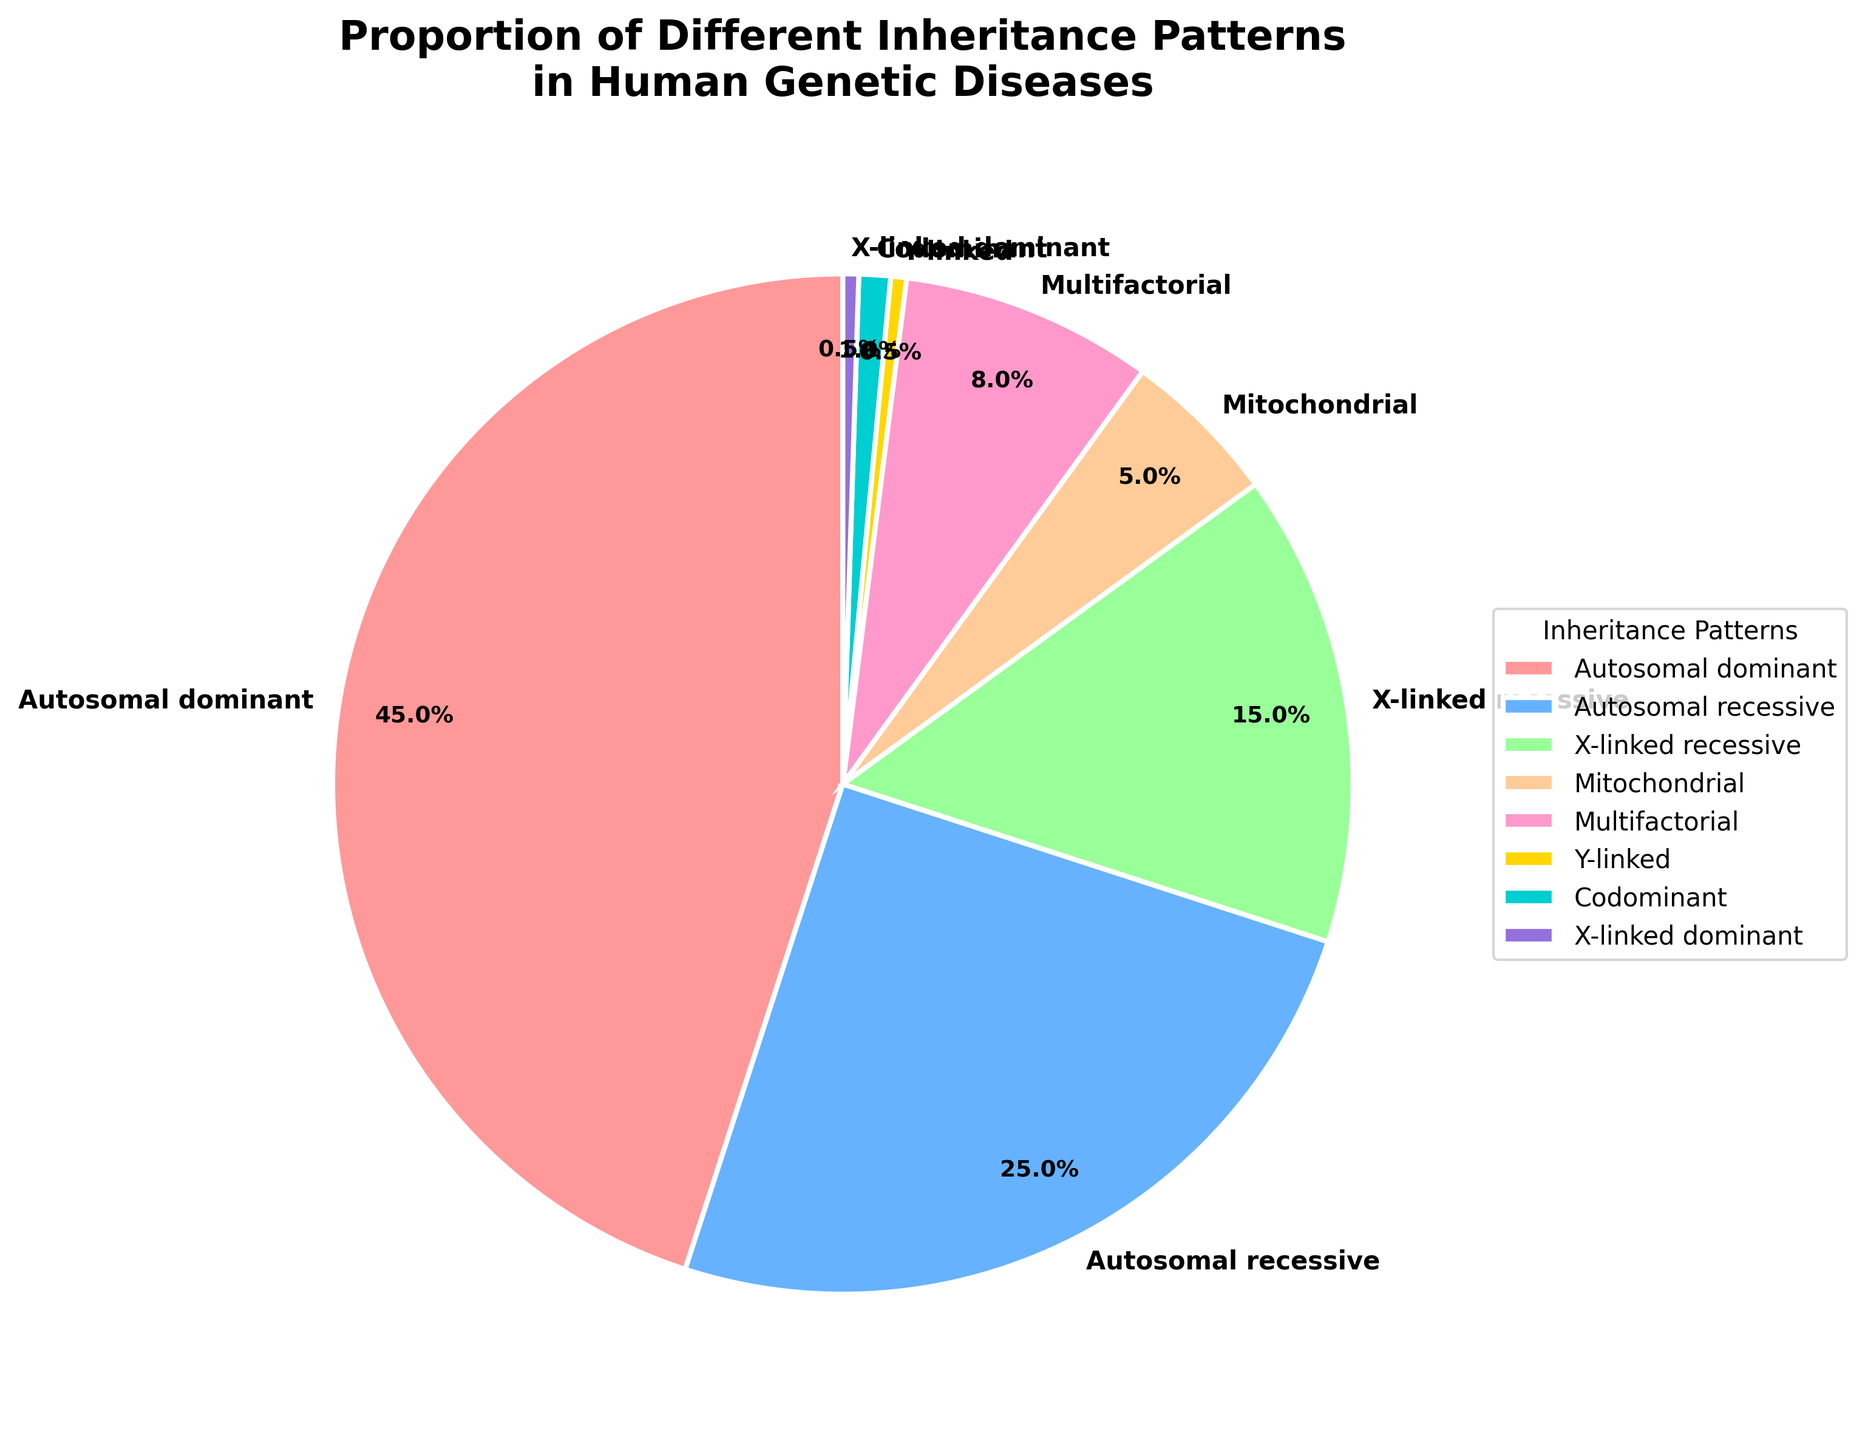What proportion of genetic diseases are inherited through Autosomal dominant patterns? From the pie chart, find the sector labeled "Autosomal dominant" and read the percentage value presented.
Answer: 45% Which inheritance pattern has the smallest representation in the pie chart? Look for the sector with the smallest percentage value. The smallest slice is labeled "Y-linked" and "X-linked dominant", both contributing 0.5%.
Answer: Y-linked and X-linked dominant How do the proportions of Autosomal recessive and Multifactorial diseases compare? Identify the percentages for both Autosomal recessive (25%) and Multifactorial (8%). Autosomal recessive has a higher proportion than Multifactorial.
Answer: Autosomal recessive is greater What are the combined percentages of X-linked recessive and Mitochondrial inheritance patterns? Add the percentages of X-linked recessive (15%) and Mitochondrial (5%). 15% + 5% = 20%.
Answer: 20% How much larger is the Autosomal dominant proportion compared to the X-linked recessive proportion? Subtract the percentage of X-linked recessive (15%) from Autosomal dominant (45%). 45% - 15% = 30%.
Answer: 30% Which inheritance pattern is represented by a blue slice in the pie chart? Identify the blue slice in the pie chart associated with a specific inheritance pattern label. The blue slice corresponds to "Autosomal recessive".
Answer: Autosomal recessive Add the proportions of all inheritance patterns except Autosomal dominant. What is the total? Add percentages of Autosomal recessive (25%), X-linked recessive (15%), Mitochondrial (5%), Multifactorial (8%), Y-linked (0.5%), Codominant (1%), and X-linked dominant (0.5%). 25% + 15% + 5% + 8% + 0.5% + 1% + 0.5% = 55%.
Answer: 55% Which inheritance pattern shares an equal proportion of 0.5% in genetic disease inheritance? Identify the slices that each represent 0.5% and their associated labels. Both Y-linked and X-linked dominant have equal proportions of 0.5%.
Answer: Y-linked and X-linked dominant Is the percentage of Mitochondrial inheritance greater than that of Codominant inheritance? Compare the percentage values of Mitochondrial (5%) and Codominant (1%). 5% is greater than 1%.
Answer: Yes 